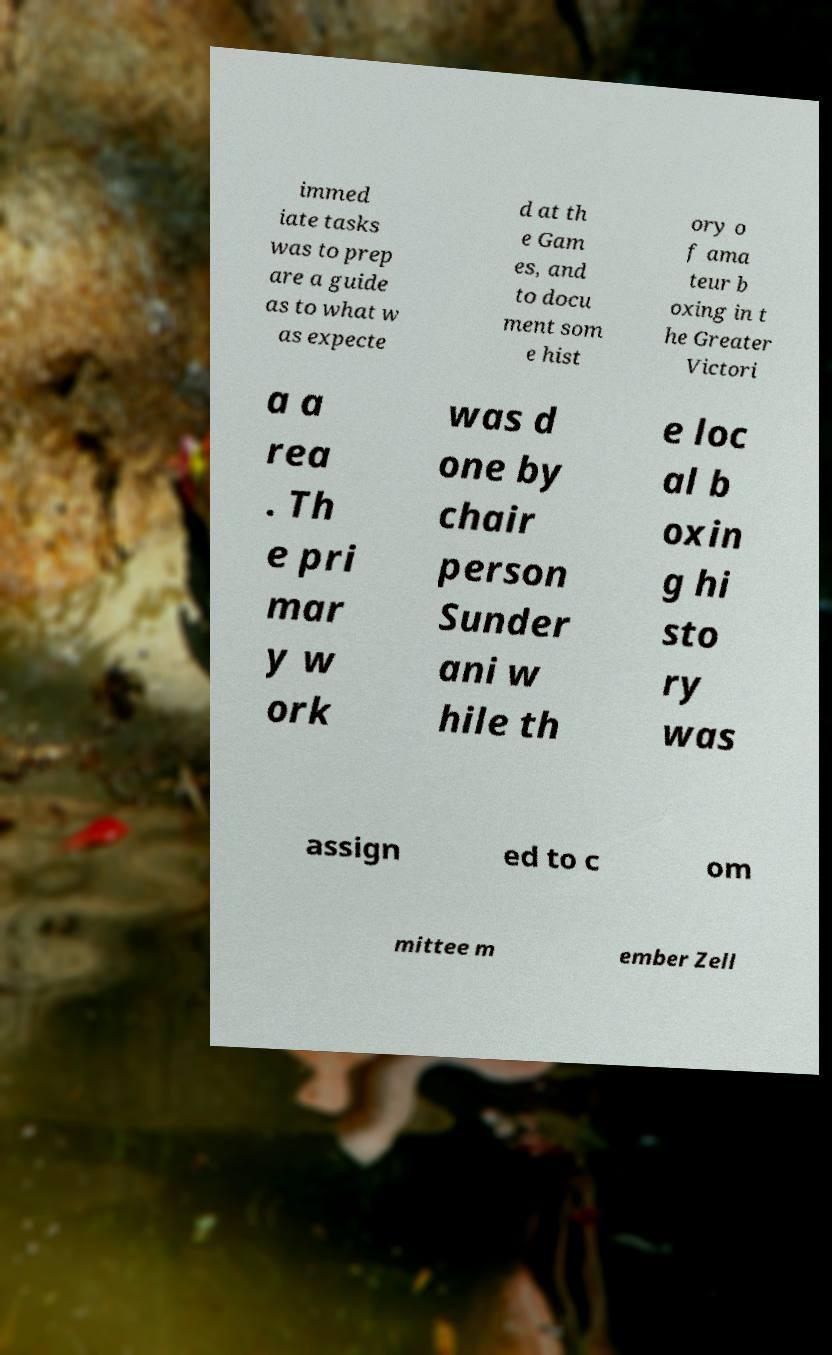Please read and relay the text visible in this image. What does it say? immed iate tasks was to prep are a guide as to what w as expecte d at th e Gam es, and to docu ment som e hist ory o f ama teur b oxing in t he Greater Victori a a rea . Th e pri mar y w ork was d one by chair person Sunder ani w hile th e loc al b oxin g hi sto ry was assign ed to c om mittee m ember Zell 